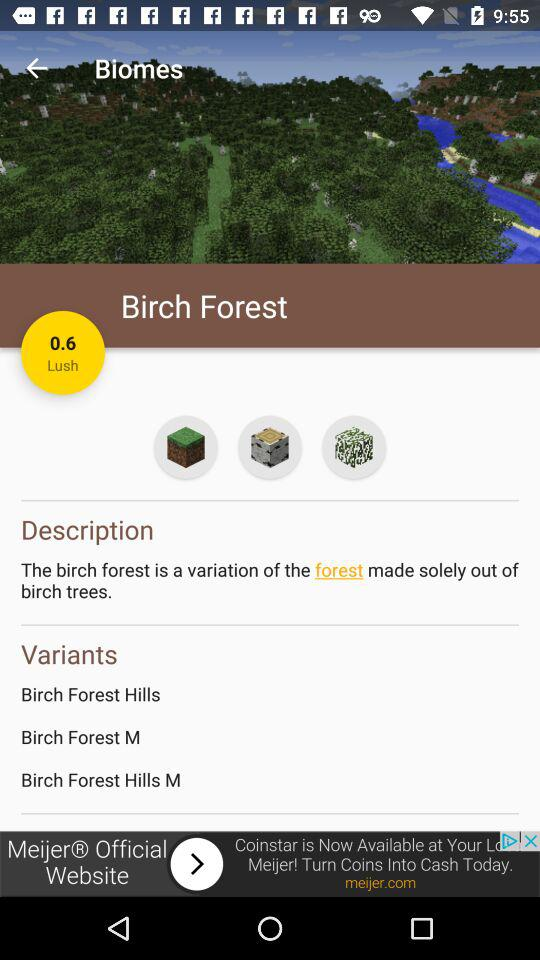What is the description of Birch Forest? The description of birch forest is "The birch forest is a variation of the forest made solely out of birch trees". 